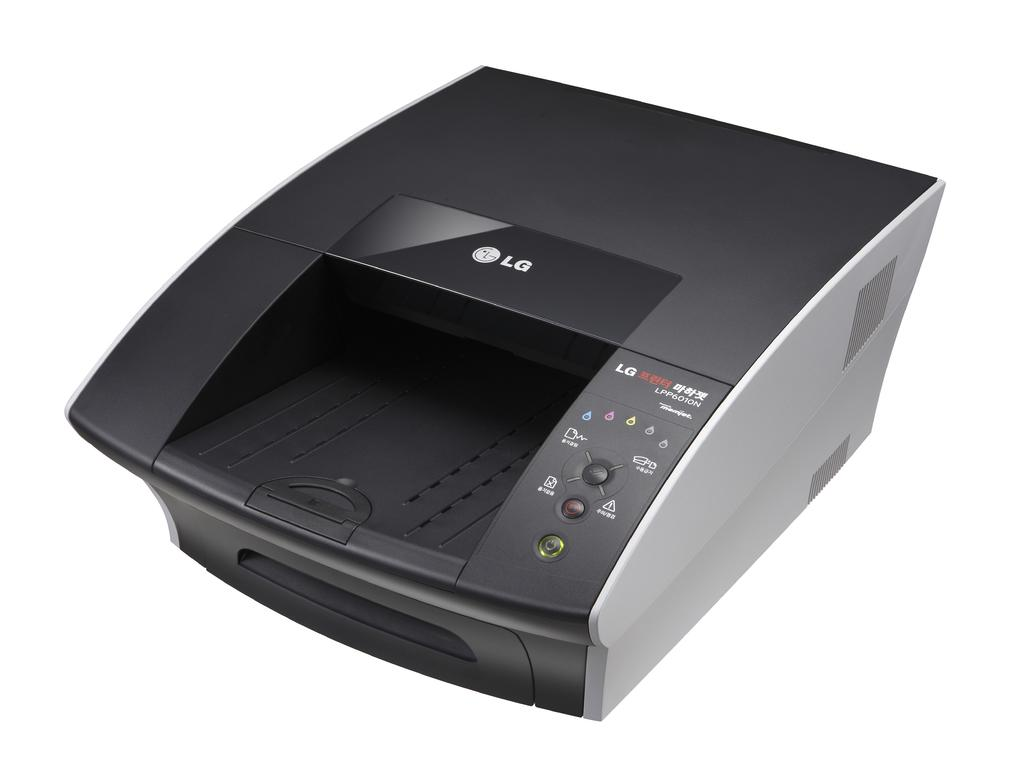What device is the main subject of the image? There is a printer in the image. What colors are used to depict the printer? The printer is black and ash in color. What color is the background of the image? The background of the image is white. Can you hear the printer coughing in the image? There is no sound in the image, and printers do not have the ability to cough. What type of vase is present on the printer in the image? There is no vase present on the printer in the image. 